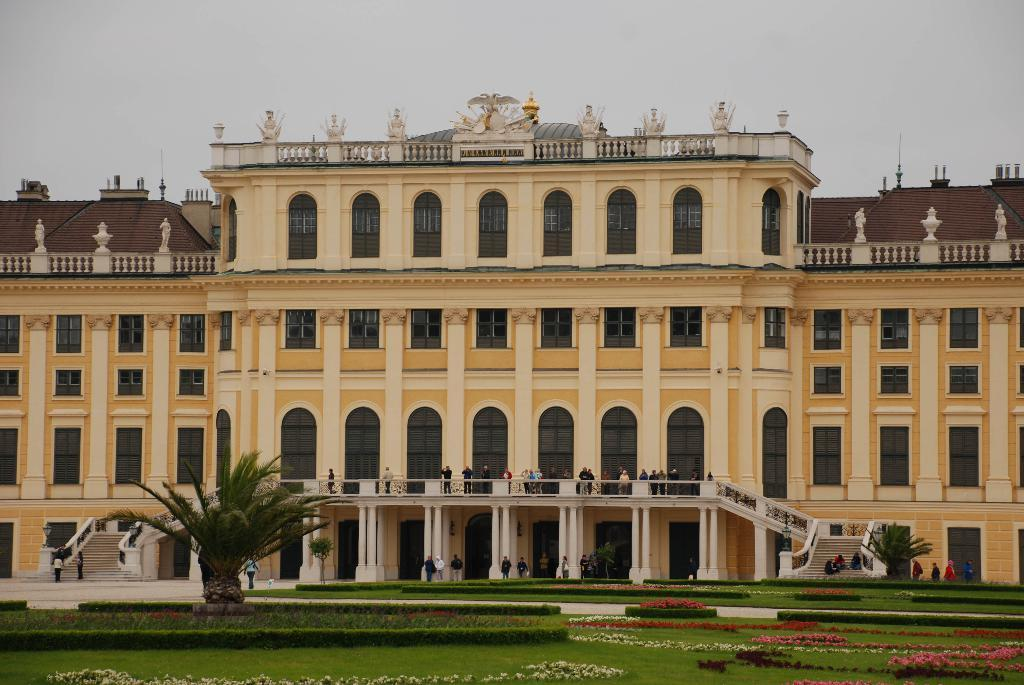What type of vegetation can be seen in the image? There is grass, flowers, and trees in the image. Are there any living beings in the image? Yes, there are people in the image. What can be seen in the background of the image? There is a building and the sky visible in the background of the image. What type of addition problem can be solved using the canvas and hook in the image? There is no canvas or hook present in the image, so it is not possible to solve any addition problems using them. 